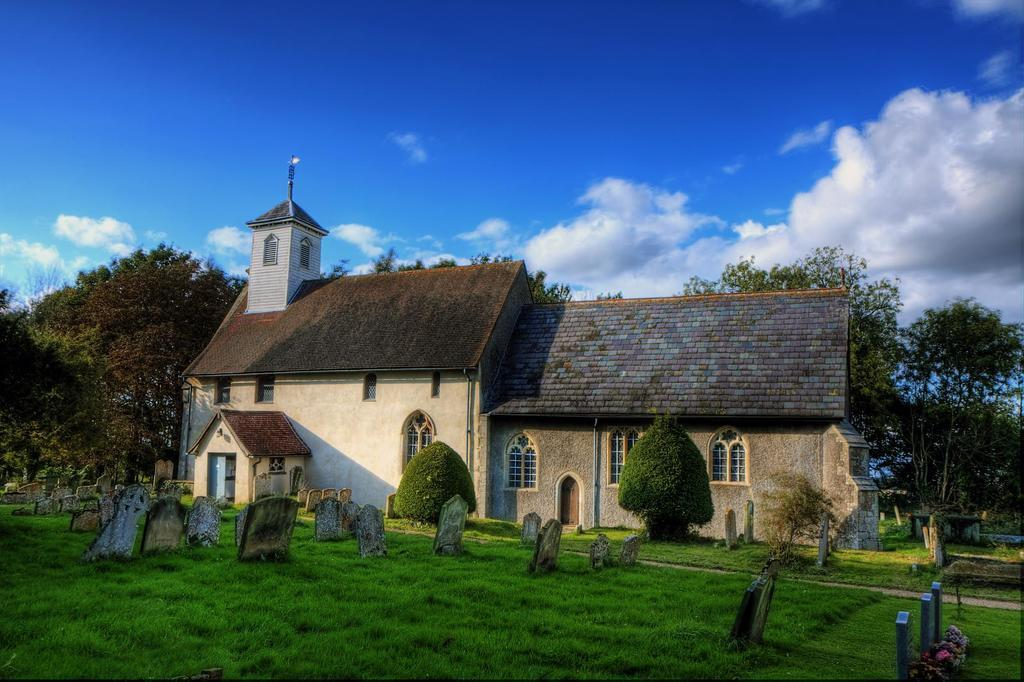What type of structure is present in the image? There is a building in the image. Can you describe the color of the building? The building has a cream and brown color. What can be seen in the background of the image? There are trees and the sky visible in the background of the image. What is the color of the trees? The trees have a green color. How would you describe the color of the sky? The sky has a blue and white color. How many birds are sitting on the stem of the tree in the image? There are no birds or stems present in the image; it features a building, trees, and the sky. 